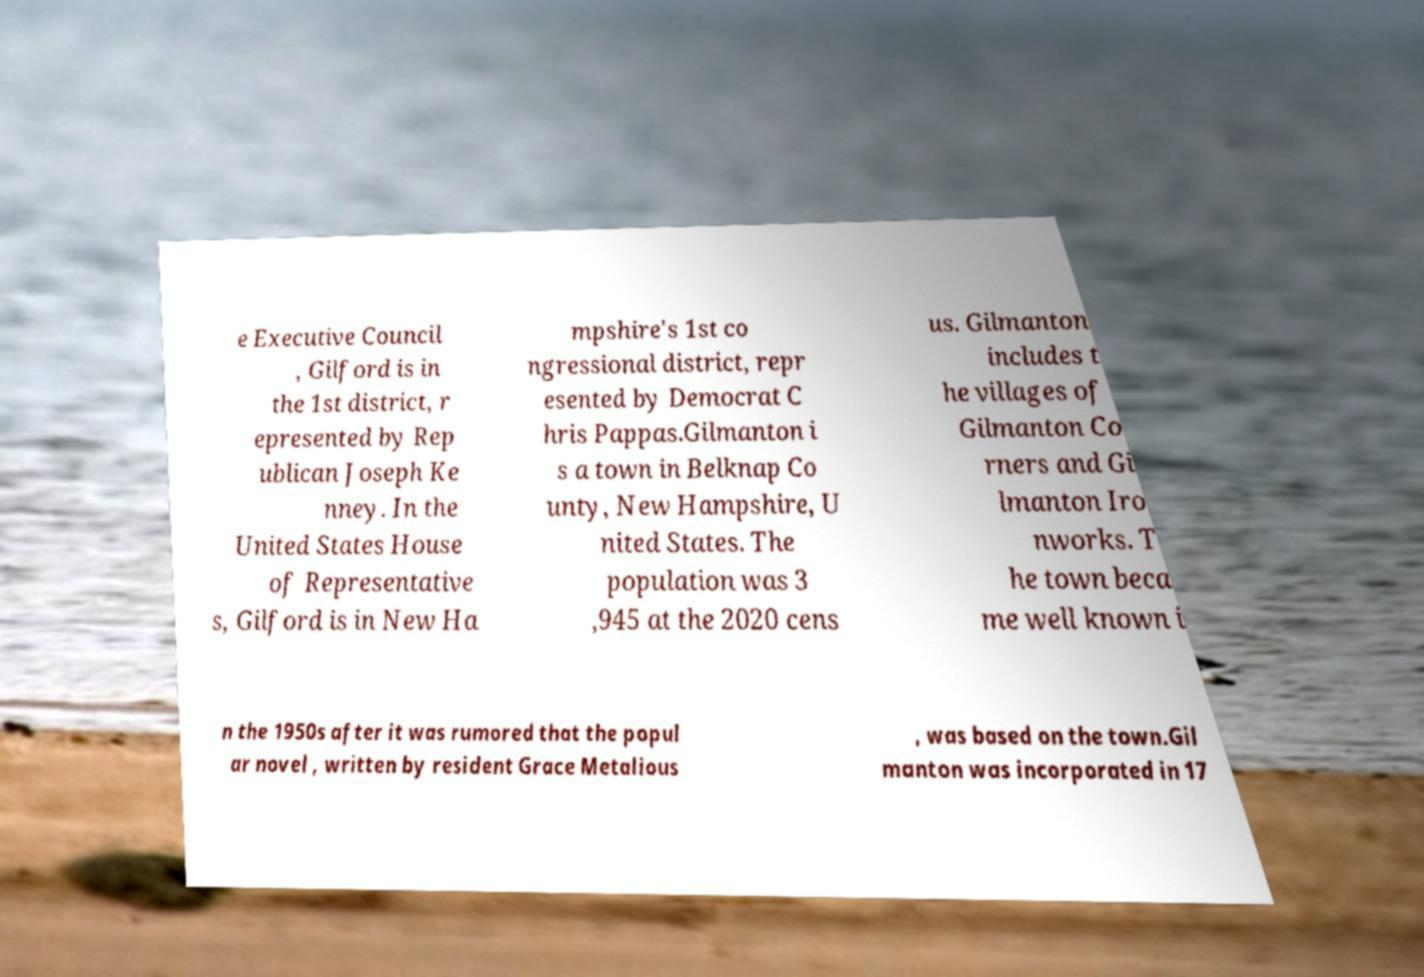Please read and relay the text visible in this image. What does it say? e Executive Council , Gilford is in the 1st district, r epresented by Rep ublican Joseph Ke nney. In the United States House of Representative s, Gilford is in New Ha mpshire's 1st co ngressional district, repr esented by Democrat C hris Pappas.Gilmanton i s a town in Belknap Co unty, New Hampshire, U nited States. The population was 3 ,945 at the 2020 cens us. Gilmanton includes t he villages of Gilmanton Co rners and Gi lmanton Iro nworks. T he town beca me well known i n the 1950s after it was rumored that the popul ar novel , written by resident Grace Metalious , was based on the town.Gil manton was incorporated in 17 